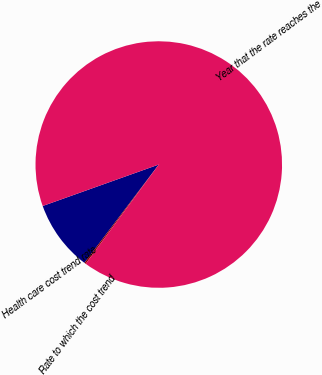Convert chart. <chart><loc_0><loc_0><loc_500><loc_500><pie_chart><fcel>Health care cost trend rate<fcel>Rate to which the cost trend<fcel>Year that the rate reaches the<nl><fcel>9.24%<fcel>0.2%<fcel>90.56%<nl></chart> 